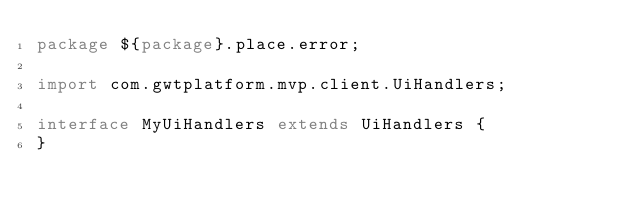Convert code to text. <code><loc_0><loc_0><loc_500><loc_500><_Java_>package ${package}.place.error;

import com.gwtplatform.mvp.client.UiHandlers;

interface MyUiHandlers extends UiHandlers {
}
</code> 